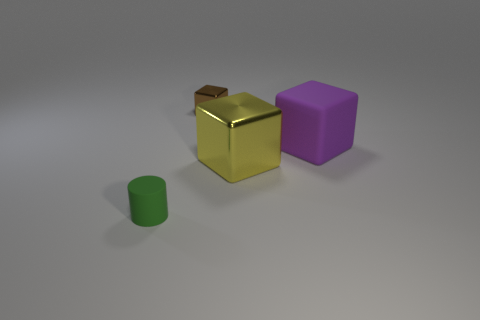Add 3 cylinders. How many objects exist? 7 Subtract all cylinders. How many objects are left? 3 Subtract all green metal balls. Subtract all large blocks. How many objects are left? 2 Add 4 small shiny blocks. How many small shiny blocks are left? 5 Add 3 large yellow metal things. How many large yellow metal things exist? 4 Subtract 1 green cylinders. How many objects are left? 3 